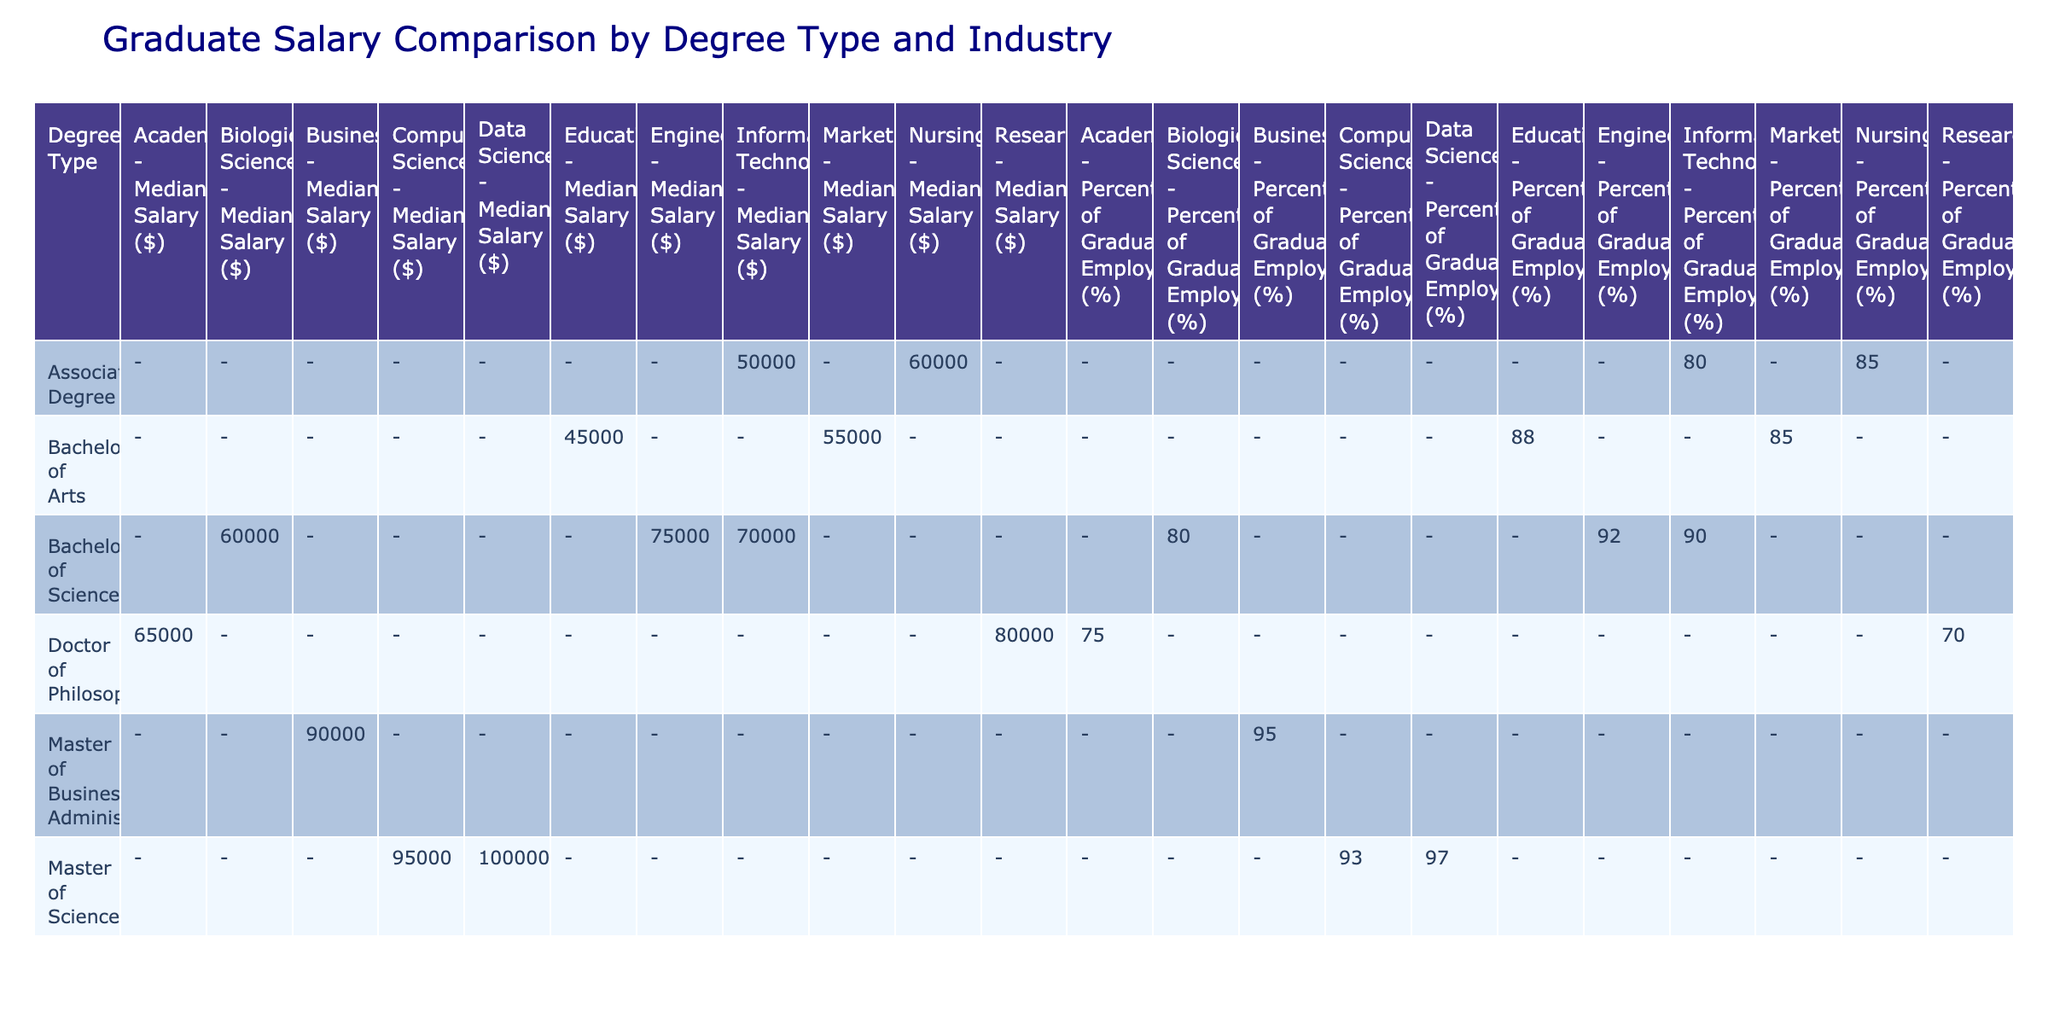What is the median salary for a Bachelor of Arts in Marketing? The table shows that the median salary for a Bachelor of Arts in Marketing under the Marketing industry is $55,000.
Answer: $55,000 Which degree type has the highest median salary in the Business industry? According to the table, the Master of Business Administration has the highest median salary in the Business industry at $90,000.
Answer: Master of Business Administration Is the percentage of graduates employed higher for Doctor of Philosophy in Research compared to Doctor of Philosophy in Academia? The table shows that the percentage of graduates employed for Doctor of Philosophy in Research is 70%, while for Doctor of Philosophy in Academia it is 75%. Therefore, the percentage for Academia is higher.
Answer: No What is the difference in median salary between a Bachelor of Science in Engineering and a Bachelor of Science in Biological Sciences? From the table, the median salary for Bachelor of Science in Engineering is $75,000 and for Biological Sciences, it is $60,000. The difference is $75,000 - $60,000 = $15,000.
Answer: $15,000 Are graduates with an Associate Degree in Nursing earning more than those with an Associate Degree in Information Technology? The table shows that the median salary for Nursing is $60,000, while for Information Technology it is $50,000. Therefore, graduates with an Associate Degree in Nursing are earning more.
Answer: Yes What is the average median salary for all the Master’s degrees listed in the table? The table lists three Master's degrees: MBA ($90,000), MS in Computer Science ($95,000), and MS in Data Science ($100,000). To find the average, sum them up: $90,000 + $95,000 + $100,000 = $285,000, then divide by 3, giving an average of $95,000.
Answer: $95,000 Which degree type has the lowest percentage of graduates employed? The table shows that the Doctor of Philosophy in Research has the lowest percentage of graduates employed at 70%.
Answer: Doctor of Philosophy in Research If we consider only Bachelor degrees, what is the median salary for the group? The median salaries for Bachelor degrees listed are $45,000 (Arts in Education), $55,000 (Arts in Marketing), $75,000 (Science in Engineering), $70,000 (Science in IT), and $60,000 (Science in Biological Sciences). When calculating the median, we first arrange them: $45,000, $55,000, $60,000, $70,000, $75,000. The median is $60,000, being the middle value.
Answer: $60,000 How many industries have a median salary of over $90,000? By reviewing the table, the industries with median salaries over $90,000 are Business (MBA - $90,000), Computer Science (MS - $95,000), and Data Science (MS - $100,000). That totals to three industries.
Answer: 3 